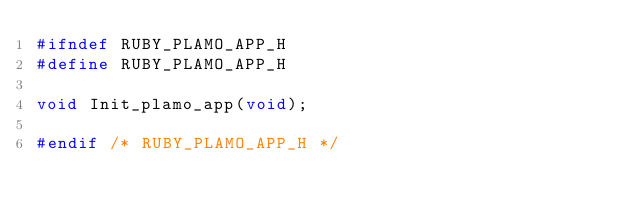Convert code to text. <code><loc_0><loc_0><loc_500><loc_500><_C_>#ifndef RUBY_PLAMO_APP_H
#define RUBY_PLAMO_APP_H

void Init_plamo_app(void);

#endif /* RUBY_PLAMO_APP_H */
</code> 